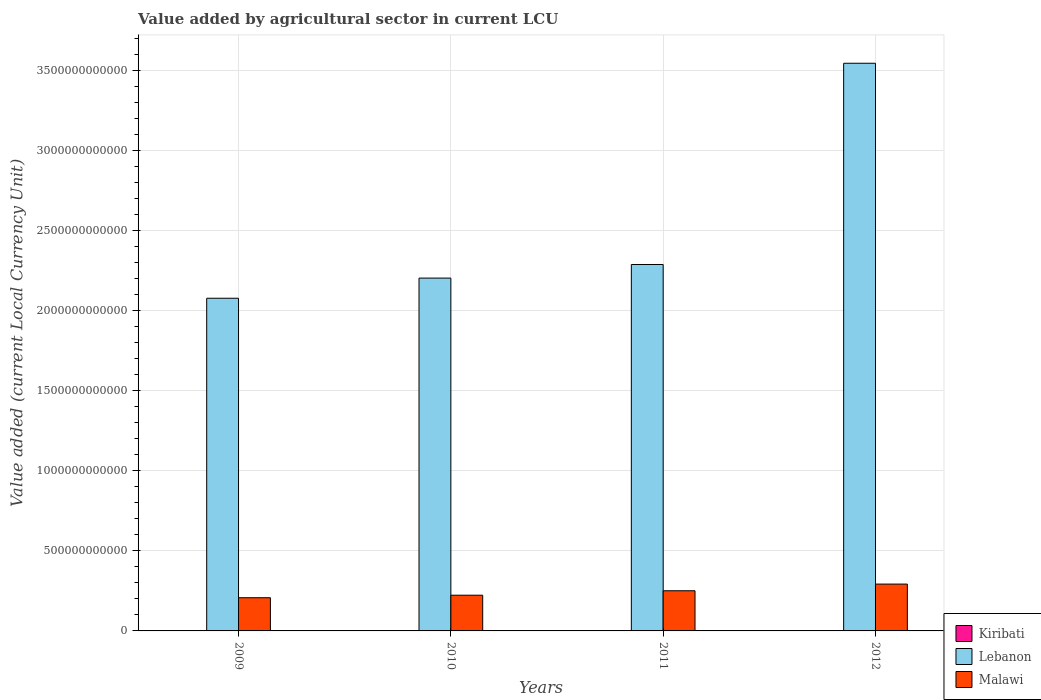How many different coloured bars are there?
Give a very brief answer. 3. How many bars are there on the 2nd tick from the right?
Your answer should be compact. 3. In how many cases, is the number of bars for a given year not equal to the number of legend labels?
Give a very brief answer. 0. What is the value added by agricultural sector in Malawi in 2010?
Give a very brief answer. 2.23e+11. Across all years, what is the maximum value added by agricultural sector in Lebanon?
Provide a succinct answer. 3.55e+12. Across all years, what is the minimum value added by agricultural sector in Malawi?
Your answer should be compact. 2.07e+11. In which year was the value added by agricultural sector in Lebanon maximum?
Offer a terse response. 2012. What is the total value added by agricultural sector in Kiribati in the graph?
Offer a very short reply. 1.62e+08. What is the difference between the value added by agricultural sector in Kiribati in 2010 and that in 2012?
Your response must be concise. -2.69e+06. What is the difference between the value added by agricultural sector in Malawi in 2011 and the value added by agricultural sector in Lebanon in 2009?
Your response must be concise. -1.83e+12. What is the average value added by agricultural sector in Kiribati per year?
Your response must be concise. 4.06e+07. In the year 2012, what is the difference between the value added by agricultural sector in Malawi and value added by agricultural sector in Lebanon?
Provide a short and direct response. -3.25e+12. What is the ratio of the value added by agricultural sector in Lebanon in 2009 to that in 2010?
Give a very brief answer. 0.94. Is the value added by agricultural sector in Kiribati in 2009 less than that in 2010?
Provide a succinct answer. Yes. What is the difference between the highest and the second highest value added by agricultural sector in Lebanon?
Provide a succinct answer. 1.26e+12. What is the difference between the highest and the lowest value added by agricultural sector in Kiribati?
Your answer should be compact. 2.81e+06. In how many years, is the value added by agricultural sector in Kiribati greater than the average value added by agricultural sector in Kiribati taken over all years?
Offer a very short reply. 2. What does the 2nd bar from the left in 2009 represents?
Your answer should be compact. Lebanon. What does the 1st bar from the right in 2012 represents?
Your answer should be compact. Malawi. Is it the case that in every year, the sum of the value added by agricultural sector in Lebanon and value added by agricultural sector in Malawi is greater than the value added by agricultural sector in Kiribati?
Keep it short and to the point. Yes. What is the difference between two consecutive major ticks on the Y-axis?
Your answer should be very brief. 5.00e+11. Does the graph contain any zero values?
Ensure brevity in your answer.  No. Does the graph contain grids?
Keep it short and to the point. Yes. How many legend labels are there?
Provide a short and direct response. 3. What is the title of the graph?
Your answer should be compact. Value added by agricultural sector in current LCU. Does "Lesotho" appear as one of the legend labels in the graph?
Your answer should be compact. No. What is the label or title of the X-axis?
Offer a very short reply. Years. What is the label or title of the Y-axis?
Provide a succinct answer. Value added (current Local Currency Unit). What is the Value added (current Local Currency Unit) of Kiribati in 2009?
Ensure brevity in your answer.  3.92e+07. What is the Value added (current Local Currency Unit) of Lebanon in 2009?
Your answer should be compact. 2.08e+12. What is the Value added (current Local Currency Unit) in Malawi in 2009?
Provide a short and direct response. 2.07e+11. What is the Value added (current Local Currency Unit) in Kiribati in 2010?
Give a very brief answer. 3.93e+07. What is the Value added (current Local Currency Unit) in Lebanon in 2010?
Provide a succinct answer. 2.20e+12. What is the Value added (current Local Currency Unit) in Malawi in 2010?
Your answer should be compact. 2.23e+11. What is the Value added (current Local Currency Unit) of Kiribati in 2011?
Give a very brief answer. 4.20e+07. What is the Value added (current Local Currency Unit) in Lebanon in 2011?
Offer a very short reply. 2.29e+12. What is the Value added (current Local Currency Unit) in Malawi in 2011?
Ensure brevity in your answer.  2.51e+11. What is the Value added (current Local Currency Unit) of Kiribati in 2012?
Give a very brief answer. 4.20e+07. What is the Value added (current Local Currency Unit) of Lebanon in 2012?
Keep it short and to the point. 3.55e+12. What is the Value added (current Local Currency Unit) of Malawi in 2012?
Make the answer very short. 2.93e+11. Across all years, what is the maximum Value added (current Local Currency Unit) of Kiribati?
Give a very brief answer. 4.20e+07. Across all years, what is the maximum Value added (current Local Currency Unit) of Lebanon?
Make the answer very short. 3.55e+12. Across all years, what is the maximum Value added (current Local Currency Unit) in Malawi?
Your answer should be compact. 2.93e+11. Across all years, what is the minimum Value added (current Local Currency Unit) in Kiribati?
Offer a terse response. 3.92e+07. Across all years, what is the minimum Value added (current Local Currency Unit) of Lebanon?
Provide a succinct answer. 2.08e+12. Across all years, what is the minimum Value added (current Local Currency Unit) of Malawi?
Offer a terse response. 2.07e+11. What is the total Value added (current Local Currency Unit) of Kiribati in the graph?
Your answer should be very brief. 1.62e+08. What is the total Value added (current Local Currency Unit) of Lebanon in the graph?
Offer a very short reply. 1.01e+13. What is the total Value added (current Local Currency Unit) of Malawi in the graph?
Offer a terse response. 9.74e+11. What is the difference between the Value added (current Local Currency Unit) of Kiribati in 2009 and that in 2010?
Your answer should be compact. -1.20e+05. What is the difference between the Value added (current Local Currency Unit) in Lebanon in 2009 and that in 2010?
Provide a succinct answer. -1.26e+11. What is the difference between the Value added (current Local Currency Unit) of Malawi in 2009 and that in 2010?
Give a very brief answer. -1.57e+1. What is the difference between the Value added (current Local Currency Unit) of Kiribati in 2009 and that in 2011?
Give a very brief answer. -2.81e+06. What is the difference between the Value added (current Local Currency Unit) in Lebanon in 2009 and that in 2011?
Give a very brief answer. -2.11e+11. What is the difference between the Value added (current Local Currency Unit) in Malawi in 2009 and that in 2011?
Offer a terse response. -4.35e+1. What is the difference between the Value added (current Local Currency Unit) of Kiribati in 2009 and that in 2012?
Make the answer very short. -2.81e+06. What is the difference between the Value added (current Local Currency Unit) of Lebanon in 2009 and that in 2012?
Give a very brief answer. -1.47e+12. What is the difference between the Value added (current Local Currency Unit) of Malawi in 2009 and that in 2012?
Make the answer very short. -8.52e+1. What is the difference between the Value added (current Local Currency Unit) in Kiribati in 2010 and that in 2011?
Offer a very short reply. -2.69e+06. What is the difference between the Value added (current Local Currency Unit) in Lebanon in 2010 and that in 2011?
Provide a short and direct response. -8.50e+1. What is the difference between the Value added (current Local Currency Unit) of Malawi in 2010 and that in 2011?
Keep it short and to the point. -2.78e+1. What is the difference between the Value added (current Local Currency Unit) in Kiribati in 2010 and that in 2012?
Give a very brief answer. -2.69e+06. What is the difference between the Value added (current Local Currency Unit) in Lebanon in 2010 and that in 2012?
Your response must be concise. -1.34e+12. What is the difference between the Value added (current Local Currency Unit) in Malawi in 2010 and that in 2012?
Your answer should be compact. -6.95e+1. What is the difference between the Value added (current Local Currency Unit) in Kiribati in 2011 and that in 2012?
Provide a succinct answer. 0. What is the difference between the Value added (current Local Currency Unit) of Lebanon in 2011 and that in 2012?
Give a very brief answer. -1.26e+12. What is the difference between the Value added (current Local Currency Unit) in Malawi in 2011 and that in 2012?
Provide a succinct answer. -4.17e+1. What is the difference between the Value added (current Local Currency Unit) of Kiribati in 2009 and the Value added (current Local Currency Unit) of Lebanon in 2010?
Offer a terse response. -2.20e+12. What is the difference between the Value added (current Local Currency Unit) in Kiribati in 2009 and the Value added (current Local Currency Unit) in Malawi in 2010?
Make the answer very short. -2.23e+11. What is the difference between the Value added (current Local Currency Unit) of Lebanon in 2009 and the Value added (current Local Currency Unit) of Malawi in 2010?
Your answer should be very brief. 1.86e+12. What is the difference between the Value added (current Local Currency Unit) of Kiribati in 2009 and the Value added (current Local Currency Unit) of Lebanon in 2011?
Make the answer very short. -2.29e+12. What is the difference between the Value added (current Local Currency Unit) of Kiribati in 2009 and the Value added (current Local Currency Unit) of Malawi in 2011?
Your answer should be compact. -2.51e+11. What is the difference between the Value added (current Local Currency Unit) of Lebanon in 2009 and the Value added (current Local Currency Unit) of Malawi in 2011?
Your response must be concise. 1.83e+12. What is the difference between the Value added (current Local Currency Unit) of Kiribati in 2009 and the Value added (current Local Currency Unit) of Lebanon in 2012?
Your response must be concise. -3.55e+12. What is the difference between the Value added (current Local Currency Unit) of Kiribati in 2009 and the Value added (current Local Currency Unit) of Malawi in 2012?
Make the answer very short. -2.93e+11. What is the difference between the Value added (current Local Currency Unit) in Lebanon in 2009 and the Value added (current Local Currency Unit) in Malawi in 2012?
Offer a very short reply. 1.79e+12. What is the difference between the Value added (current Local Currency Unit) in Kiribati in 2010 and the Value added (current Local Currency Unit) in Lebanon in 2011?
Offer a terse response. -2.29e+12. What is the difference between the Value added (current Local Currency Unit) of Kiribati in 2010 and the Value added (current Local Currency Unit) of Malawi in 2011?
Provide a succinct answer. -2.51e+11. What is the difference between the Value added (current Local Currency Unit) of Lebanon in 2010 and the Value added (current Local Currency Unit) of Malawi in 2011?
Make the answer very short. 1.95e+12. What is the difference between the Value added (current Local Currency Unit) in Kiribati in 2010 and the Value added (current Local Currency Unit) in Lebanon in 2012?
Offer a terse response. -3.55e+12. What is the difference between the Value added (current Local Currency Unit) in Kiribati in 2010 and the Value added (current Local Currency Unit) in Malawi in 2012?
Ensure brevity in your answer.  -2.93e+11. What is the difference between the Value added (current Local Currency Unit) of Lebanon in 2010 and the Value added (current Local Currency Unit) of Malawi in 2012?
Offer a very short reply. 1.91e+12. What is the difference between the Value added (current Local Currency Unit) in Kiribati in 2011 and the Value added (current Local Currency Unit) in Lebanon in 2012?
Offer a very short reply. -3.55e+12. What is the difference between the Value added (current Local Currency Unit) of Kiribati in 2011 and the Value added (current Local Currency Unit) of Malawi in 2012?
Offer a very short reply. -2.93e+11. What is the difference between the Value added (current Local Currency Unit) in Lebanon in 2011 and the Value added (current Local Currency Unit) in Malawi in 2012?
Provide a succinct answer. 2.00e+12. What is the average Value added (current Local Currency Unit) of Kiribati per year?
Keep it short and to the point. 4.06e+07. What is the average Value added (current Local Currency Unit) in Lebanon per year?
Ensure brevity in your answer.  2.53e+12. What is the average Value added (current Local Currency Unit) of Malawi per year?
Ensure brevity in your answer.  2.44e+11. In the year 2009, what is the difference between the Value added (current Local Currency Unit) in Kiribati and Value added (current Local Currency Unit) in Lebanon?
Keep it short and to the point. -2.08e+12. In the year 2009, what is the difference between the Value added (current Local Currency Unit) of Kiribati and Value added (current Local Currency Unit) of Malawi?
Make the answer very short. -2.07e+11. In the year 2009, what is the difference between the Value added (current Local Currency Unit) in Lebanon and Value added (current Local Currency Unit) in Malawi?
Your answer should be very brief. 1.87e+12. In the year 2010, what is the difference between the Value added (current Local Currency Unit) of Kiribati and Value added (current Local Currency Unit) of Lebanon?
Your response must be concise. -2.20e+12. In the year 2010, what is the difference between the Value added (current Local Currency Unit) of Kiribati and Value added (current Local Currency Unit) of Malawi?
Your response must be concise. -2.23e+11. In the year 2010, what is the difference between the Value added (current Local Currency Unit) in Lebanon and Value added (current Local Currency Unit) in Malawi?
Your answer should be very brief. 1.98e+12. In the year 2011, what is the difference between the Value added (current Local Currency Unit) of Kiribati and Value added (current Local Currency Unit) of Lebanon?
Your response must be concise. -2.29e+12. In the year 2011, what is the difference between the Value added (current Local Currency Unit) of Kiribati and Value added (current Local Currency Unit) of Malawi?
Offer a very short reply. -2.51e+11. In the year 2011, what is the difference between the Value added (current Local Currency Unit) of Lebanon and Value added (current Local Currency Unit) of Malawi?
Make the answer very short. 2.04e+12. In the year 2012, what is the difference between the Value added (current Local Currency Unit) in Kiribati and Value added (current Local Currency Unit) in Lebanon?
Provide a succinct answer. -3.55e+12. In the year 2012, what is the difference between the Value added (current Local Currency Unit) in Kiribati and Value added (current Local Currency Unit) in Malawi?
Keep it short and to the point. -2.93e+11. In the year 2012, what is the difference between the Value added (current Local Currency Unit) in Lebanon and Value added (current Local Currency Unit) in Malawi?
Make the answer very short. 3.25e+12. What is the ratio of the Value added (current Local Currency Unit) of Lebanon in 2009 to that in 2010?
Offer a terse response. 0.94. What is the ratio of the Value added (current Local Currency Unit) in Malawi in 2009 to that in 2010?
Your answer should be very brief. 0.93. What is the ratio of the Value added (current Local Currency Unit) in Kiribati in 2009 to that in 2011?
Ensure brevity in your answer.  0.93. What is the ratio of the Value added (current Local Currency Unit) of Lebanon in 2009 to that in 2011?
Make the answer very short. 0.91. What is the ratio of the Value added (current Local Currency Unit) of Malawi in 2009 to that in 2011?
Keep it short and to the point. 0.83. What is the ratio of the Value added (current Local Currency Unit) in Kiribati in 2009 to that in 2012?
Provide a succinct answer. 0.93. What is the ratio of the Value added (current Local Currency Unit) in Lebanon in 2009 to that in 2012?
Offer a terse response. 0.59. What is the ratio of the Value added (current Local Currency Unit) of Malawi in 2009 to that in 2012?
Ensure brevity in your answer.  0.71. What is the ratio of the Value added (current Local Currency Unit) of Kiribati in 2010 to that in 2011?
Your response must be concise. 0.94. What is the ratio of the Value added (current Local Currency Unit) of Lebanon in 2010 to that in 2011?
Keep it short and to the point. 0.96. What is the ratio of the Value added (current Local Currency Unit) of Malawi in 2010 to that in 2011?
Keep it short and to the point. 0.89. What is the ratio of the Value added (current Local Currency Unit) in Kiribati in 2010 to that in 2012?
Offer a terse response. 0.94. What is the ratio of the Value added (current Local Currency Unit) of Lebanon in 2010 to that in 2012?
Offer a very short reply. 0.62. What is the ratio of the Value added (current Local Currency Unit) in Malawi in 2010 to that in 2012?
Your answer should be very brief. 0.76. What is the ratio of the Value added (current Local Currency Unit) of Kiribati in 2011 to that in 2012?
Keep it short and to the point. 1. What is the ratio of the Value added (current Local Currency Unit) in Lebanon in 2011 to that in 2012?
Your response must be concise. 0.65. What is the ratio of the Value added (current Local Currency Unit) of Malawi in 2011 to that in 2012?
Offer a very short reply. 0.86. What is the difference between the highest and the second highest Value added (current Local Currency Unit) in Lebanon?
Your answer should be compact. 1.26e+12. What is the difference between the highest and the second highest Value added (current Local Currency Unit) in Malawi?
Make the answer very short. 4.17e+1. What is the difference between the highest and the lowest Value added (current Local Currency Unit) of Kiribati?
Make the answer very short. 2.81e+06. What is the difference between the highest and the lowest Value added (current Local Currency Unit) of Lebanon?
Give a very brief answer. 1.47e+12. What is the difference between the highest and the lowest Value added (current Local Currency Unit) of Malawi?
Your answer should be compact. 8.52e+1. 